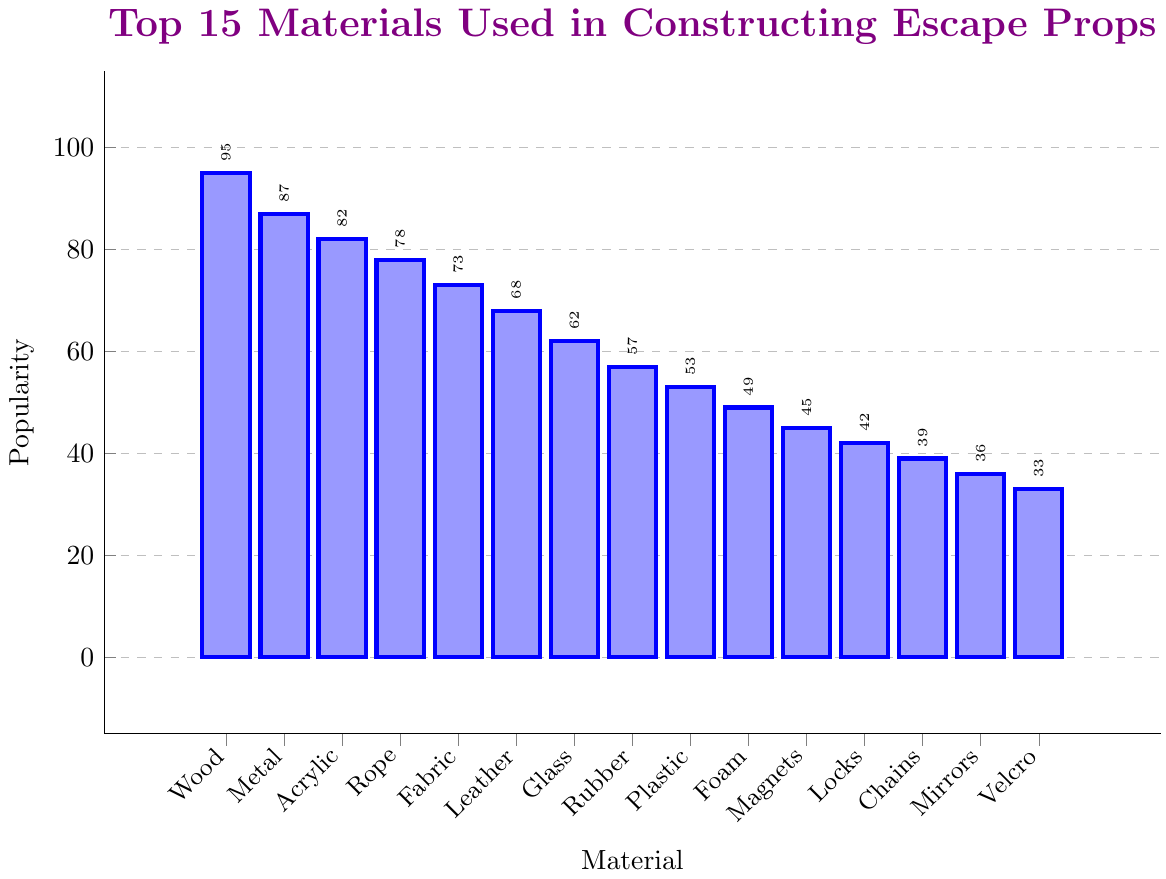Which material is the most popular in constructing escape props? The figure's bar indicating "Wood" has the highest height among all materials, which represents the highest popularity score.
Answer: Wood What is the difference in popularity between Wood and Metal? The popularity score for Wood is 95, and for Metal, it is 87. The difference is calculated as 95 - 87 = 8.
Answer: 8 What material shows approximately half the popularity of Wood? The popularity of Wood is 95. Half of 95 is approximately 47. Among the materials, "Foam" has a popularity score of 49, which is closest to half of Wood's score.
Answer: Foam Which is more popular, Rope or Fabric? By comparing the heights of the bars, Rope has a popularity score of 78 and Fabric has a score of 73. Since 78 > 73, Rope is more popular than Fabric.
Answer: Rope What materials have a popularity score higher than 60? Materials with bars higher than the 60-mark are Wood (95), Metal (87), Acrylic (82), Rope (78), Fabric (73), Leather (68), and Glass (62).
Answer: Wood, Metal, Acrylic, Rope, Fabric, Leather, Glass What is the sum of the popularity scores of the top three materials? The top three materials and their popularity scores are Wood (95), Metal (87), and Acrylic (82). The sum is calculated as 95 + 87 + 82 = 264.
Answer: 264 Which color represents the bars in the figure? All bars are filled with a shade of blue, indicating they are visually represented by the color blue.
Answer: Blue How many bars are there representing the materials in the chart? The number of bars can be counted directly from the figure, and there are 15 bars in total.
Answer: 15 What is the popularity score of the least used material in constructing escape props? The bar for "Velcro" has the lowest height among all materials, signifying a popularity score of 33.
Answer: 33 What is the average popularity score of the materials listed? Summing all popularity scores: 95 + 87 + 82 + 78 + 73 + 68 + 62 + 57 + 53 + 49 + 45 + 42 + 39 + 36 + 33 = 899. Dividing by the number of materials (15) gives an average popularity score of 899 / 15 = 59.93.
Answer: 59.93 